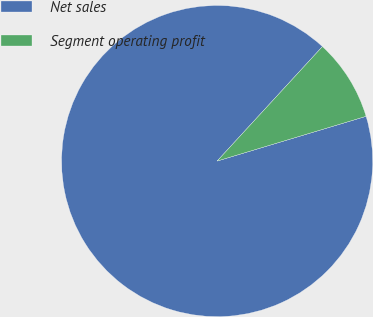<chart> <loc_0><loc_0><loc_500><loc_500><pie_chart><fcel>Net sales<fcel>Segment operating profit<nl><fcel>91.48%<fcel>8.52%<nl></chart> 